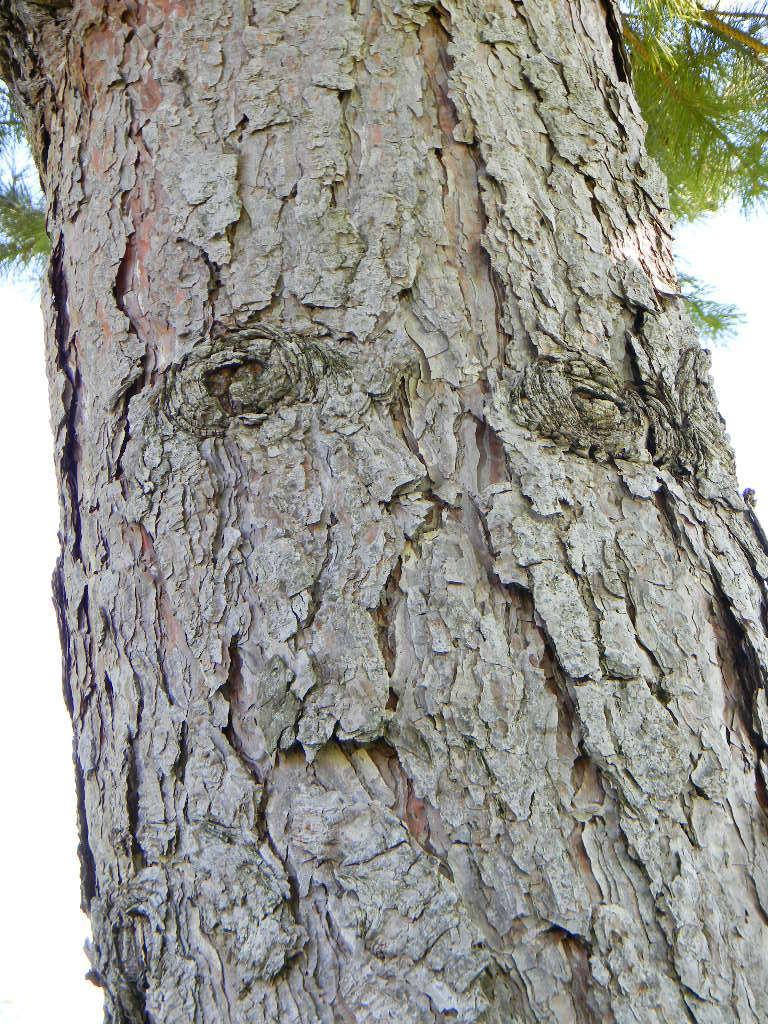What is present on the tree branch in the image? There are plants on the tree branch in the image. What part of the natural environment can be seen in the image? A part of the sky is visible in the image. Can you describe the tree branch in the image? The tree branch has plants growing on it. What type of toys can be seen on the tree branch in the image? There are no toys present on the tree branch in the image; it only has plants. 